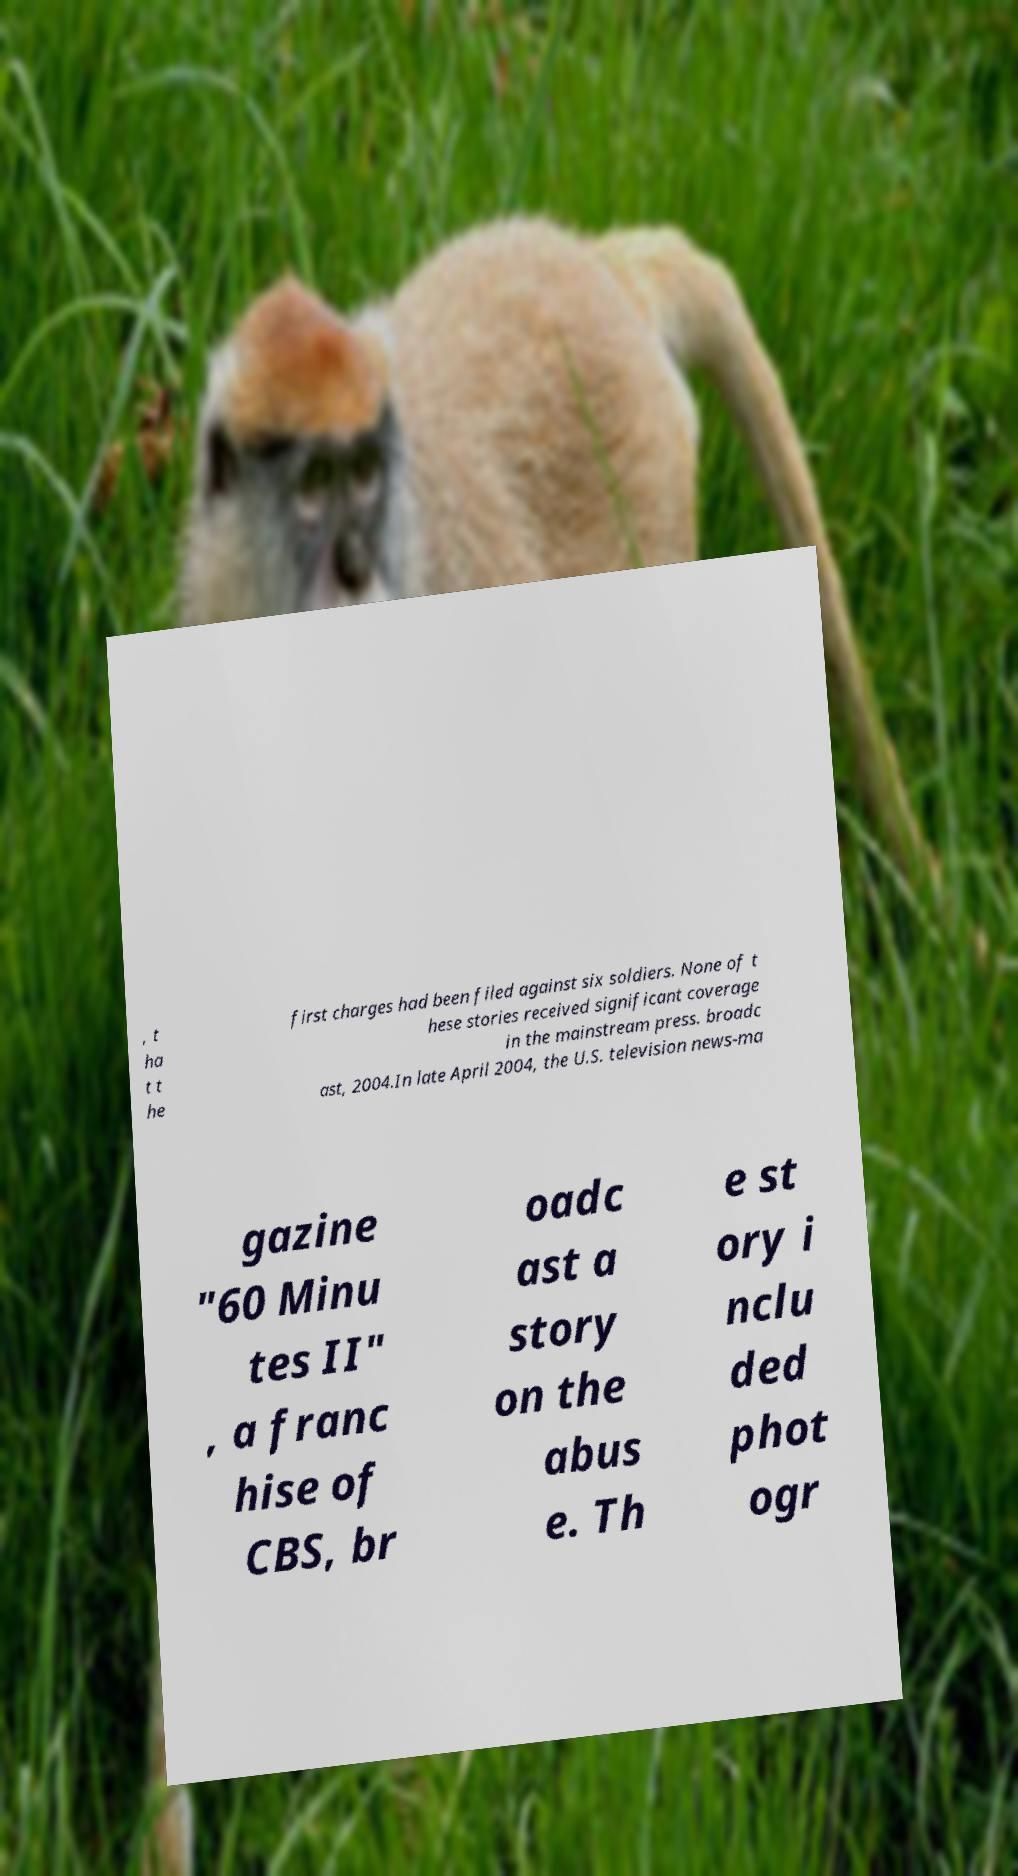What messages or text are displayed in this image? I need them in a readable, typed format. , t ha t t he first charges had been filed against six soldiers. None of t hese stories received significant coverage in the mainstream press. broadc ast, 2004.In late April 2004, the U.S. television news-ma gazine "60 Minu tes II" , a franc hise of CBS, br oadc ast a story on the abus e. Th e st ory i nclu ded phot ogr 